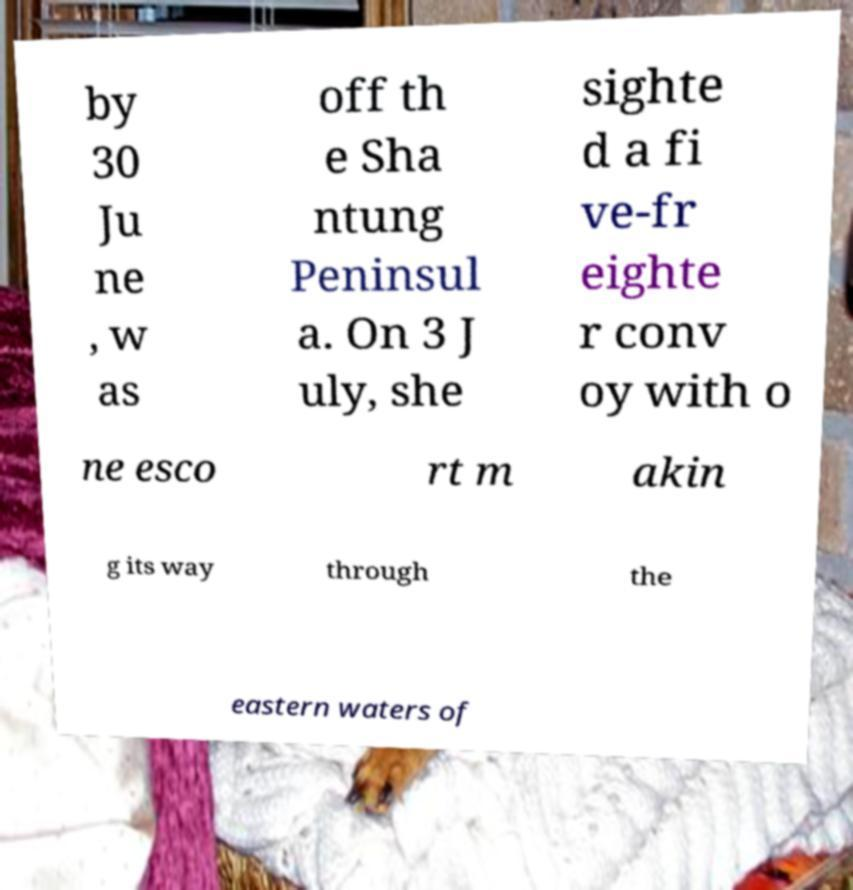What messages or text are displayed in this image? I need them in a readable, typed format. by 30 Ju ne , w as off th e Sha ntung Peninsul a. On 3 J uly, she sighte d a fi ve-fr eighte r conv oy with o ne esco rt m akin g its way through the eastern waters of 